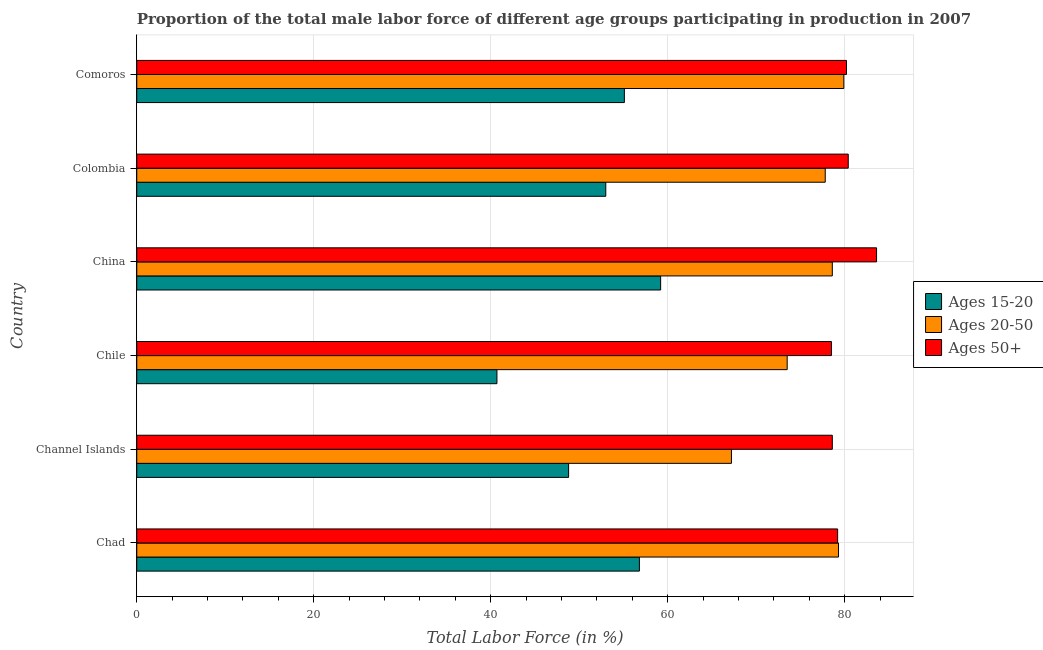Are the number of bars on each tick of the Y-axis equal?
Provide a succinct answer. Yes. What is the label of the 1st group of bars from the top?
Your answer should be compact. Comoros. In how many cases, is the number of bars for a given country not equal to the number of legend labels?
Offer a very short reply. 0. What is the percentage of male labor force within the age group 15-20 in Channel Islands?
Your response must be concise. 48.8. Across all countries, what is the maximum percentage of male labor force within the age group 15-20?
Make the answer very short. 59.2. Across all countries, what is the minimum percentage of male labor force within the age group 20-50?
Offer a very short reply. 67.2. In which country was the percentage of male labor force above age 50 maximum?
Give a very brief answer. China. What is the total percentage of male labor force within the age group 15-20 in the graph?
Offer a very short reply. 313.6. What is the difference between the percentage of male labor force within the age group 15-20 in Channel Islands and that in Chile?
Give a very brief answer. 8.1. What is the difference between the percentage of male labor force within the age group 20-50 in Colombia and the percentage of male labor force within the age group 15-20 in Comoros?
Your answer should be very brief. 22.7. What is the average percentage of male labor force above age 50 per country?
Your answer should be very brief. 80.08. What is the difference between the percentage of male labor force within the age group 20-50 and percentage of male labor force within the age group 15-20 in Chad?
Keep it short and to the point. 22.5. In how many countries, is the percentage of male labor force above age 50 greater than 60 %?
Provide a short and direct response. 6. What is the ratio of the percentage of male labor force above age 50 in Channel Islands to that in Colombia?
Your response must be concise. 0.98. Is the difference between the percentage of male labor force above age 50 in China and Colombia greater than the difference between the percentage of male labor force within the age group 20-50 in China and Colombia?
Provide a short and direct response. Yes. What is the difference between the highest and the second highest percentage of male labor force within the age group 20-50?
Your answer should be compact. 0.6. What is the difference between the highest and the lowest percentage of male labor force within the age group 15-20?
Offer a very short reply. 18.5. In how many countries, is the percentage of male labor force above age 50 greater than the average percentage of male labor force above age 50 taken over all countries?
Keep it short and to the point. 3. Is the sum of the percentage of male labor force within the age group 20-50 in Chad and Channel Islands greater than the maximum percentage of male labor force above age 50 across all countries?
Your answer should be very brief. Yes. What does the 1st bar from the top in Colombia represents?
Ensure brevity in your answer.  Ages 50+. What does the 1st bar from the bottom in Chad represents?
Provide a short and direct response. Ages 15-20. Is it the case that in every country, the sum of the percentage of male labor force within the age group 15-20 and percentage of male labor force within the age group 20-50 is greater than the percentage of male labor force above age 50?
Keep it short and to the point. Yes. How many bars are there?
Give a very brief answer. 18. Are all the bars in the graph horizontal?
Offer a terse response. Yes. What is the difference between two consecutive major ticks on the X-axis?
Keep it short and to the point. 20. Does the graph contain grids?
Your response must be concise. Yes. How are the legend labels stacked?
Provide a short and direct response. Vertical. What is the title of the graph?
Make the answer very short. Proportion of the total male labor force of different age groups participating in production in 2007. Does "Coal" appear as one of the legend labels in the graph?
Give a very brief answer. No. What is the label or title of the X-axis?
Your answer should be compact. Total Labor Force (in %). What is the Total Labor Force (in %) in Ages 15-20 in Chad?
Provide a succinct answer. 56.8. What is the Total Labor Force (in %) in Ages 20-50 in Chad?
Your answer should be compact. 79.3. What is the Total Labor Force (in %) of Ages 50+ in Chad?
Ensure brevity in your answer.  79.2. What is the Total Labor Force (in %) in Ages 15-20 in Channel Islands?
Ensure brevity in your answer.  48.8. What is the Total Labor Force (in %) in Ages 20-50 in Channel Islands?
Your answer should be very brief. 67.2. What is the Total Labor Force (in %) of Ages 50+ in Channel Islands?
Ensure brevity in your answer.  78.6. What is the Total Labor Force (in %) of Ages 15-20 in Chile?
Your answer should be very brief. 40.7. What is the Total Labor Force (in %) of Ages 20-50 in Chile?
Keep it short and to the point. 73.5. What is the Total Labor Force (in %) in Ages 50+ in Chile?
Your answer should be very brief. 78.5. What is the Total Labor Force (in %) in Ages 15-20 in China?
Provide a succinct answer. 59.2. What is the Total Labor Force (in %) in Ages 20-50 in China?
Offer a very short reply. 78.6. What is the Total Labor Force (in %) in Ages 50+ in China?
Provide a short and direct response. 83.6. What is the Total Labor Force (in %) in Ages 20-50 in Colombia?
Offer a very short reply. 77.8. What is the Total Labor Force (in %) in Ages 50+ in Colombia?
Your answer should be compact. 80.4. What is the Total Labor Force (in %) in Ages 15-20 in Comoros?
Give a very brief answer. 55.1. What is the Total Labor Force (in %) of Ages 20-50 in Comoros?
Offer a very short reply. 79.9. What is the Total Labor Force (in %) of Ages 50+ in Comoros?
Provide a succinct answer. 80.2. Across all countries, what is the maximum Total Labor Force (in %) of Ages 15-20?
Offer a terse response. 59.2. Across all countries, what is the maximum Total Labor Force (in %) in Ages 20-50?
Ensure brevity in your answer.  79.9. Across all countries, what is the maximum Total Labor Force (in %) in Ages 50+?
Offer a terse response. 83.6. Across all countries, what is the minimum Total Labor Force (in %) in Ages 15-20?
Make the answer very short. 40.7. Across all countries, what is the minimum Total Labor Force (in %) in Ages 20-50?
Ensure brevity in your answer.  67.2. Across all countries, what is the minimum Total Labor Force (in %) of Ages 50+?
Provide a short and direct response. 78.5. What is the total Total Labor Force (in %) in Ages 15-20 in the graph?
Offer a very short reply. 313.6. What is the total Total Labor Force (in %) in Ages 20-50 in the graph?
Provide a short and direct response. 456.3. What is the total Total Labor Force (in %) in Ages 50+ in the graph?
Keep it short and to the point. 480.5. What is the difference between the Total Labor Force (in %) in Ages 20-50 in Chad and that in Channel Islands?
Your answer should be very brief. 12.1. What is the difference between the Total Labor Force (in %) of Ages 15-20 in Chad and that in Chile?
Make the answer very short. 16.1. What is the difference between the Total Labor Force (in %) of Ages 20-50 in Chad and that in China?
Your answer should be compact. 0.7. What is the difference between the Total Labor Force (in %) in Ages 15-20 in Chad and that in Colombia?
Make the answer very short. 3.8. What is the difference between the Total Labor Force (in %) of Ages 20-50 in Chad and that in Colombia?
Your answer should be very brief. 1.5. What is the difference between the Total Labor Force (in %) of Ages 50+ in Chad and that in Colombia?
Ensure brevity in your answer.  -1.2. What is the difference between the Total Labor Force (in %) of Ages 20-50 in Channel Islands and that in Chile?
Provide a short and direct response. -6.3. What is the difference between the Total Labor Force (in %) in Ages 15-20 in Channel Islands and that in China?
Provide a short and direct response. -10.4. What is the difference between the Total Labor Force (in %) of Ages 20-50 in Channel Islands and that in China?
Keep it short and to the point. -11.4. What is the difference between the Total Labor Force (in %) in Ages 50+ in Channel Islands and that in China?
Your answer should be very brief. -5. What is the difference between the Total Labor Force (in %) in Ages 20-50 in Channel Islands and that in Colombia?
Give a very brief answer. -10.6. What is the difference between the Total Labor Force (in %) in Ages 50+ in Channel Islands and that in Colombia?
Your answer should be very brief. -1.8. What is the difference between the Total Labor Force (in %) in Ages 15-20 in Channel Islands and that in Comoros?
Your response must be concise. -6.3. What is the difference between the Total Labor Force (in %) of Ages 15-20 in Chile and that in China?
Your answer should be compact. -18.5. What is the difference between the Total Labor Force (in %) of Ages 50+ in Chile and that in China?
Provide a short and direct response. -5.1. What is the difference between the Total Labor Force (in %) of Ages 20-50 in Chile and that in Colombia?
Your response must be concise. -4.3. What is the difference between the Total Labor Force (in %) in Ages 15-20 in Chile and that in Comoros?
Offer a very short reply. -14.4. What is the difference between the Total Labor Force (in %) in Ages 50+ in China and that in Colombia?
Keep it short and to the point. 3.2. What is the difference between the Total Labor Force (in %) of Ages 15-20 in China and that in Comoros?
Provide a succinct answer. 4.1. What is the difference between the Total Labor Force (in %) of Ages 50+ in China and that in Comoros?
Give a very brief answer. 3.4. What is the difference between the Total Labor Force (in %) in Ages 15-20 in Colombia and that in Comoros?
Provide a succinct answer. -2.1. What is the difference between the Total Labor Force (in %) in Ages 50+ in Colombia and that in Comoros?
Your response must be concise. 0.2. What is the difference between the Total Labor Force (in %) in Ages 15-20 in Chad and the Total Labor Force (in %) in Ages 50+ in Channel Islands?
Give a very brief answer. -21.8. What is the difference between the Total Labor Force (in %) in Ages 15-20 in Chad and the Total Labor Force (in %) in Ages 20-50 in Chile?
Provide a short and direct response. -16.7. What is the difference between the Total Labor Force (in %) in Ages 15-20 in Chad and the Total Labor Force (in %) in Ages 50+ in Chile?
Provide a short and direct response. -21.7. What is the difference between the Total Labor Force (in %) in Ages 20-50 in Chad and the Total Labor Force (in %) in Ages 50+ in Chile?
Offer a terse response. 0.8. What is the difference between the Total Labor Force (in %) in Ages 15-20 in Chad and the Total Labor Force (in %) in Ages 20-50 in China?
Your response must be concise. -21.8. What is the difference between the Total Labor Force (in %) of Ages 15-20 in Chad and the Total Labor Force (in %) of Ages 50+ in China?
Your answer should be very brief. -26.8. What is the difference between the Total Labor Force (in %) in Ages 15-20 in Chad and the Total Labor Force (in %) in Ages 50+ in Colombia?
Give a very brief answer. -23.6. What is the difference between the Total Labor Force (in %) of Ages 15-20 in Chad and the Total Labor Force (in %) of Ages 20-50 in Comoros?
Offer a very short reply. -23.1. What is the difference between the Total Labor Force (in %) in Ages 15-20 in Chad and the Total Labor Force (in %) in Ages 50+ in Comoros?
Make the answer very short. -23.4. What is the difference between the Total Labor Force (in %) in Ages 20-50 in Chad and the Total Labor Force (in %) in Ages 50+ in Comoros?
Make the answer very short. -0.9. What is the difference between the Total Labor Force (in %) in Ages 15-20 in Channel Islands and the Total Labor Force (in %) in Ages 20-50 in Chile?
Make the answer very short. -24.7. What is the difference between the Total Labor Force (in %) in Ages 15-20 in Channel Islands and the Total Labor Force (in %) in Ages 50+ in Chile?
Give a very brief answer. -29.7. What is the difference between the Total Labor Force (in %) of Ages 20-50 in Channel Islands and the Total Labor Force (in %) of Ages 50+ in Chile?
Ensure brevity in your answer.  -11.3. What is the difference between the Total Labor Force (in %) of Ages 15-20 in Channel Islands and the Total Labor Force (in %) of Ages 20-50 in China?
Provide a short and direct response. -29.8. What is the difference between the Total Labor Force (in %) of Ages 15-20 in Channel Islands and the Total Labor Force (in %) of Ages 50+ in China?
Your answer should be compact. -34.8. What is the difference between the Total Labor Force (in %) in Ages 20-50 in Channel Islands and the Total Labor Force (in %) in Ages 50+ in China?
Offer a very short reply. -16.4. What is the difference between the Total Labor Force (in %) in Ages 15-20 in Channel Islands and the Total Labor Force (in %) in Ages 50+ in Colombia?
Your answer should be very brief. -31.6. What is the difference between the Total Labor Force (in %) in Ages 15-20 in Channel Islands and the Total Labor Force (in %) in Ages 20-50 in Comoros?
Provide a succinct answer. -31.1. What is the difference between the Total Labor Force (in %) of Ages 15-20 in Channel Islands and the Total Labor Force (in %) of Ages 50+ in Comoros?
Your answer should be compact. -31.4. What is the difference between the Total Labor Force (in %) in Ages 20-50 in Channel Islands and the Total Labor Force (in %) in Ages 50+ in Comoros?
Ensure brevity in your answer.  -13. What is the difference between the Total Labor Force (in %) of Ages 15-20 in Chile and the Total Labor Force (in %) of Ages 20-50 in China?
Keep it short and to the point. -37.9. What is the difference between the Total Labor Force (in %) in Ages 15-20 in Chile and the Total Labor Force (in %) in Ages 50+ in China?
Your response must be concise. -42.9. What is the difference between the Total Labor Force (in %) in Ages 15-20 in Chile and the Total Labor Force (in %) in Ages 20-50 in Colombia?
Your response must be concise. -37.1. What is the difference between the Total Labor Force (in %) in Ages 15-20 in Chile and the Total Labor Force (in %) in Ages 50+ in Colombia?
Your answer should be compact. -39.7. What is the difference between the Total Labor Force (in %) of Ages 15-20 in Chile and the Total Labor Force (in %) of Ages 20-50 in Comoros?
Offer a very short reply. -39.2. What is the difference between the Total Labor Force (in %) of Ages 15-20 in Chile and the Total Labor Force (in %) of Ages 50+ in Comoros?
Your answer should be compact. -39.5. What is the difference between the Total Labor Force (in %) of Ages 15-20 in China and the Total Labor Force (in %) of Ages 20-50 in Colombia?
Your answer should be compact. -18.6. What is the difference between the Total Labor Force (in %) of Ages 15-20 in China and the Total Labor Force (in %) of Ages 50+ in Colombia?
Give a very brief answer. -21.2. What is the difference between the Total Labor Force (in %) in Ages 20-50 in China and the Total Labor Force (in %) in Ages 50+ in Colombia?
Provide a short and direct response. -1.8. What is the difference between the Total Labor Force (in %) in Ages 15-20 in China and the Total Labor Force (in %) in Ages 20-50 in Comoros?
Your answer should be compact. -20.7. What is the difference between the Total Labor Force (in %) in Ages 20-50 in China and the Total Labor Force (in %) in Ages 50+ in Comoros?
Your response must be concise. -1.6. What is the difference between the Total Labor Force (in %) of Ages 15-20 in Colombia and the Total Labor Force (in %) of Ages 20-50 in Comoros?
Make the answer very short. -26.9. What is the difference between the Total Labor Force (in %) in Ages 15-20 in Colombia and the Total Labor Force (in %) in Ages 50+ in Comoros?
Make the answer very short. -27.2. What is the average Total Labor Force (in %) of Ages 15-20 per country?
Provide a succinct answer. 52.27. What is the average Total Labor Force (in %) of Ages 20-50 per country?
Provide a short and direct response. 76.05. What is the average Total Labor Force (in %) in Ages 50+ per country?
Make the answer very short. 80.08. What is the difference between the Total Labor Force (in %) of Ages 15-20 and Total Labor Force (in %) of Ages 20-50 in Chad?
Provide a short and direct response. -22.5. What is the difference between the Total Labor Force (in %) of Ages 15-20 and Total Labor Force (in %) of Ages 50+ in Chad?
Keep it short and to the point. -22.4. What is the difference between the Total Labor Force (in %) of Ages 20-50 and Total Labor Force (in %) of Ages 50+ in Chad?
Provide a short and direct response. 0.1. What is the difference between the Total Labor Force (in %) in Ages 15-20 and Total Labor Force (in %) in Ages 20-50 in Channel Islands?
Provide a succinct answer. -18.4. What is the difference between the Total Labor Force (in %) of Ages 15-20 and Total Labor Force (in %) of Ages 50+ in Channel Islands?
Provide a succinct answer. -29.8. What is the difference between the Total Labor Force (in %) in Ages 20-50 and Total Labor Force (in %) in Ages 50+ in Channel Islands?
Your answer should be compact. -11.4. What is the difference between the Total Labor Force (in %) of Ages 15-20 and Total Labor Force (in %) of Ages 20-50 in Chile?
Keep it short and to the point. -32.8. What is the difference between the Total Labor Force (in %) in Ages 15-20 and Total Labor Force (in %) in Ages 50+ in Chile?
Offer a terse response. -37.8. What is the difference between the Total Labor Force (in %) in Ages 15-20 and Total Labor Force (in %) in Ages 20-50 in China?
Offer a very short reply. -19.4. What is the difference between the Total Labor Force (in %) in Ages 15-20 and Total Labor Force (in %) in Ages 50+ in China?
Offer a terse response. -24.4. What is the difference between the Total Labor Force (in %) in Ages 15-20 and Total Labor Force (in %) in Ages 20-50 in Colombia?
Your response must be concise. -24.8. What is the difference between the Total Labor Force (in %) in Ages 15-20 and Total Labor Force (in %) in Ages 50+ in Colombia?
Give a very brief answer. -27.4. What is the difference between the Total Labor Force (in %) of Ages 20-50 and Total Labor Force (in %) of Ages 50+ in Colombia?
Your answer should be very brief. -2.6. What is the difference between the Total Labor Force (in %) in Ages 15-20 and Total Labor Force (in %) in Ages 20-50 in Comoros?
Provide a short and direct response. -24.8. What is the difference between the Total Labor Force (in %) of Ages 15-20 and Total Labor Force (in %) of Ages 50+ in Comoros?
Give a very brief answer. -25.1. What is the difference between the Total Labor Force (in %) of Ages 20-50 and Total Labor Force (in %) of Ages 50+ in Comoros?
Offer a terse response. -0.3. What is the ratio of the Total Labor Force (in %) of Ages 15-20 in Chad to that in Channel Islands?
Ensure brevity in your answer.  1.16. What is the ratio of the Total Labor Force (in %) of Ages 20-50 in Chad to that in Channel Islands?
Give a very brief answer. 1.18. What is the ratio of the Total Labor Force (in %) of Ages 50+ in Chad to that in Channel Islands?
Give a very brief answer. 1.01. What is the ratio of the Total Labor Force (in %) in Ages 15-20 in Chad to that in Chile?
Offer a very short reply. 1.4. What is the ratio of the Total Labor Force (in %) in Ages 20-50 in Chad to that in Chile?
Make the answer very short. 1.08. What is the ratio of the Total Labor Force (in %) in Ages 50+ in Chad to that in Chile?
Offer a terse response. 1.01. What is the ratio of the Total Labor Force (in %) of Ages 15-20 in Chad to that in China?
Offer a terse response. 0.96. What is the ratio of the Total Labor Force (in %) of Ages 20-50 in Chad to that in China?
Your answer should be very brief. 1.01. What is the ratio of the Total Labor Force (in %) of Ages 50+ in Chad to that in China?
Offer a very short reply. 0.95. What is the ratio of the Total Labor Force (in %) in Ages 15-20 in Chad to that in Colombia?
Ensure brevity in your answer.  1.07. What is the ratio of the Total Labor Force (in %) of Ages 20-50 in Chad to that in Colombia?
Your answer should be very brief. 1.02. What is the ratio of the Total Labor Force (in %) of Ages 50+ in Chad to that in Colombia?
Make the answer very short. 0.99. What is the ratio of the Total Labor Force (in %) of Ages 15-20 in Chad to that in Comoros?
Keep it short and to the point. 1.03. What is the ratio of the Total Labor Force (in %) in Ages 50+ in Chad to that in Comoros?
Offer a terse response. 0.99. What is the ratio of the Total Labor Force (in %) in Ages 15-20 in Channel Islands to that in Chile?
Offer a terse response. 1.2. What is the ratio of the Total Labor Force (in %) in Ages 20-50 in Channel Islands to that in Chile?
Ensure brevity in your answer.  0.91. What is the ratio of the Total Labor Force (in %) in Ages 50+ in Channel Islands to that in Chile?
Provide a succinct answer. 1. What is the ratio of the Total Labor Force (in %) of Ages 15-20 in Channel Islands to that in China?
Ensure brevity in your answer.  0.82. What is the ratio of the Total Labor Force (in %) of Ages 20-50 in Channel Islands to that in China?
Ensure brevity in your answer.  0.85. What is the ratio of the Total Labor Force (in %) of Ages 50+ in Channel Islands to that in China?
Give a very brief answer. 0.94. What is the ratio of the Total Labor Force (in %) of Ages 15-20 in Channel Islands to that in Colombia?
Your answer should be compact. 0.92. What is the ratio of the Total Labor Force (in %) of Ages 20-50 in Channel Islands to that in Colombia?
Ensure brevity in your answer.  0.86. What is the ratio of the Total Labor Force (in %) of Ages 50+ in Channel Islands to that in Colombia?
Offer a very short reply. 0.98. What is the ratio of the Total Labor Force (in %) of Ages 15-20 in Channel Islands to that in Comoros?
Offer a terse response. 0.89. What is the ratio of the Total Labor Force (in %) of Ages 20-50 in Channel Islands to that in Comoros?
Your answer should be very brief. 0.84. What is the ratio of the Total Labor Force (in %) in Ages 15-20 in Chile to that in China?
Offer a terse response. 0.69. What is the ratio of the Total Labor Force (in %) in Ages 20-50 in Chile to that in China?
Make the answer very short. 0.94. What is the ratio of the Total Labor Force (in %) in Ages 50+ in Chile to that in China?
Offer a terse response. 0.94. What is the ratio of the Total Labor Force (in %) of Ages 15-20 in Chile to that in Colombia?
Your answer should be compact. 0.77. What is the ratio of the Total Labor Force (in %) of Ages 20-50 in Chile to that in Colombia?
Keep it short and to the point. 0.94. What is the ratio of the Total Labor Force (in %) of Ages 50+ in Chile to that in Colombia?
Give a very brief answer. 0.98. What is the ratio of the Total Labor Force (in %) in Ages 15-20 in Chile to that in Comoros?
Your answer should be very brief. 0.74. What is the ratio of the Total Labor Force (in %) in Ages 20-50 in Chile to that in Comoros?
Ensure brevity in your answer.  0.92. What is the ratio of the Total Labor Force (in %) in Ages 50+ in Chile to that in Comoros?
Ensure brevity in your answer.  0.98. What is the ratio of the Total Labor Force (in %) of Ages 15-20 in China to that in Colombia?
Make the answer very short. 1.12. What is the ratio of the Total Labor Force (in %) of Ages 20-50 in China to that in Colombia?
Provide a short and direct response. 1.01. What is the ratio of the Total Labor Force (in %) in Ages 50+ in China to that in Colombia?
Provide a short and direct response. 1.04. What is the ratio of the Total Labor Force (in %) of Ages 15-20 in China to that in Comoros?
Your answer should be very brief. 1.07. What is the ratio of the Total Labor Force (in %) in Ages 20-50 in China to that in Comoros?
Give a very brief answer. 0.98. What is the ratio of the Total Labor Force (in %) in Ages 50+ in China to that in Comoros?
Offer a terse response. 1.04. What is the ratio of the Total Labor Force (in %) in Ages 15-20 in Colombia to that in Comoros?
Provide a short and direct response. 0.96. What is the ratio of the Total Labor Force (in %) of Ages 20-50 in Colombia to that in Comoros?
Provide a succinct answer. 0.97. What is the difference between the highest and the second highest Total Labor Force (in %) in Ages 15-20?
Keep it short and to the point. 2.4. What is the difference between the highest and the lowest Total Labor Force (in %) of Ages 15-20?
Give a very brief answer. 18.5. 